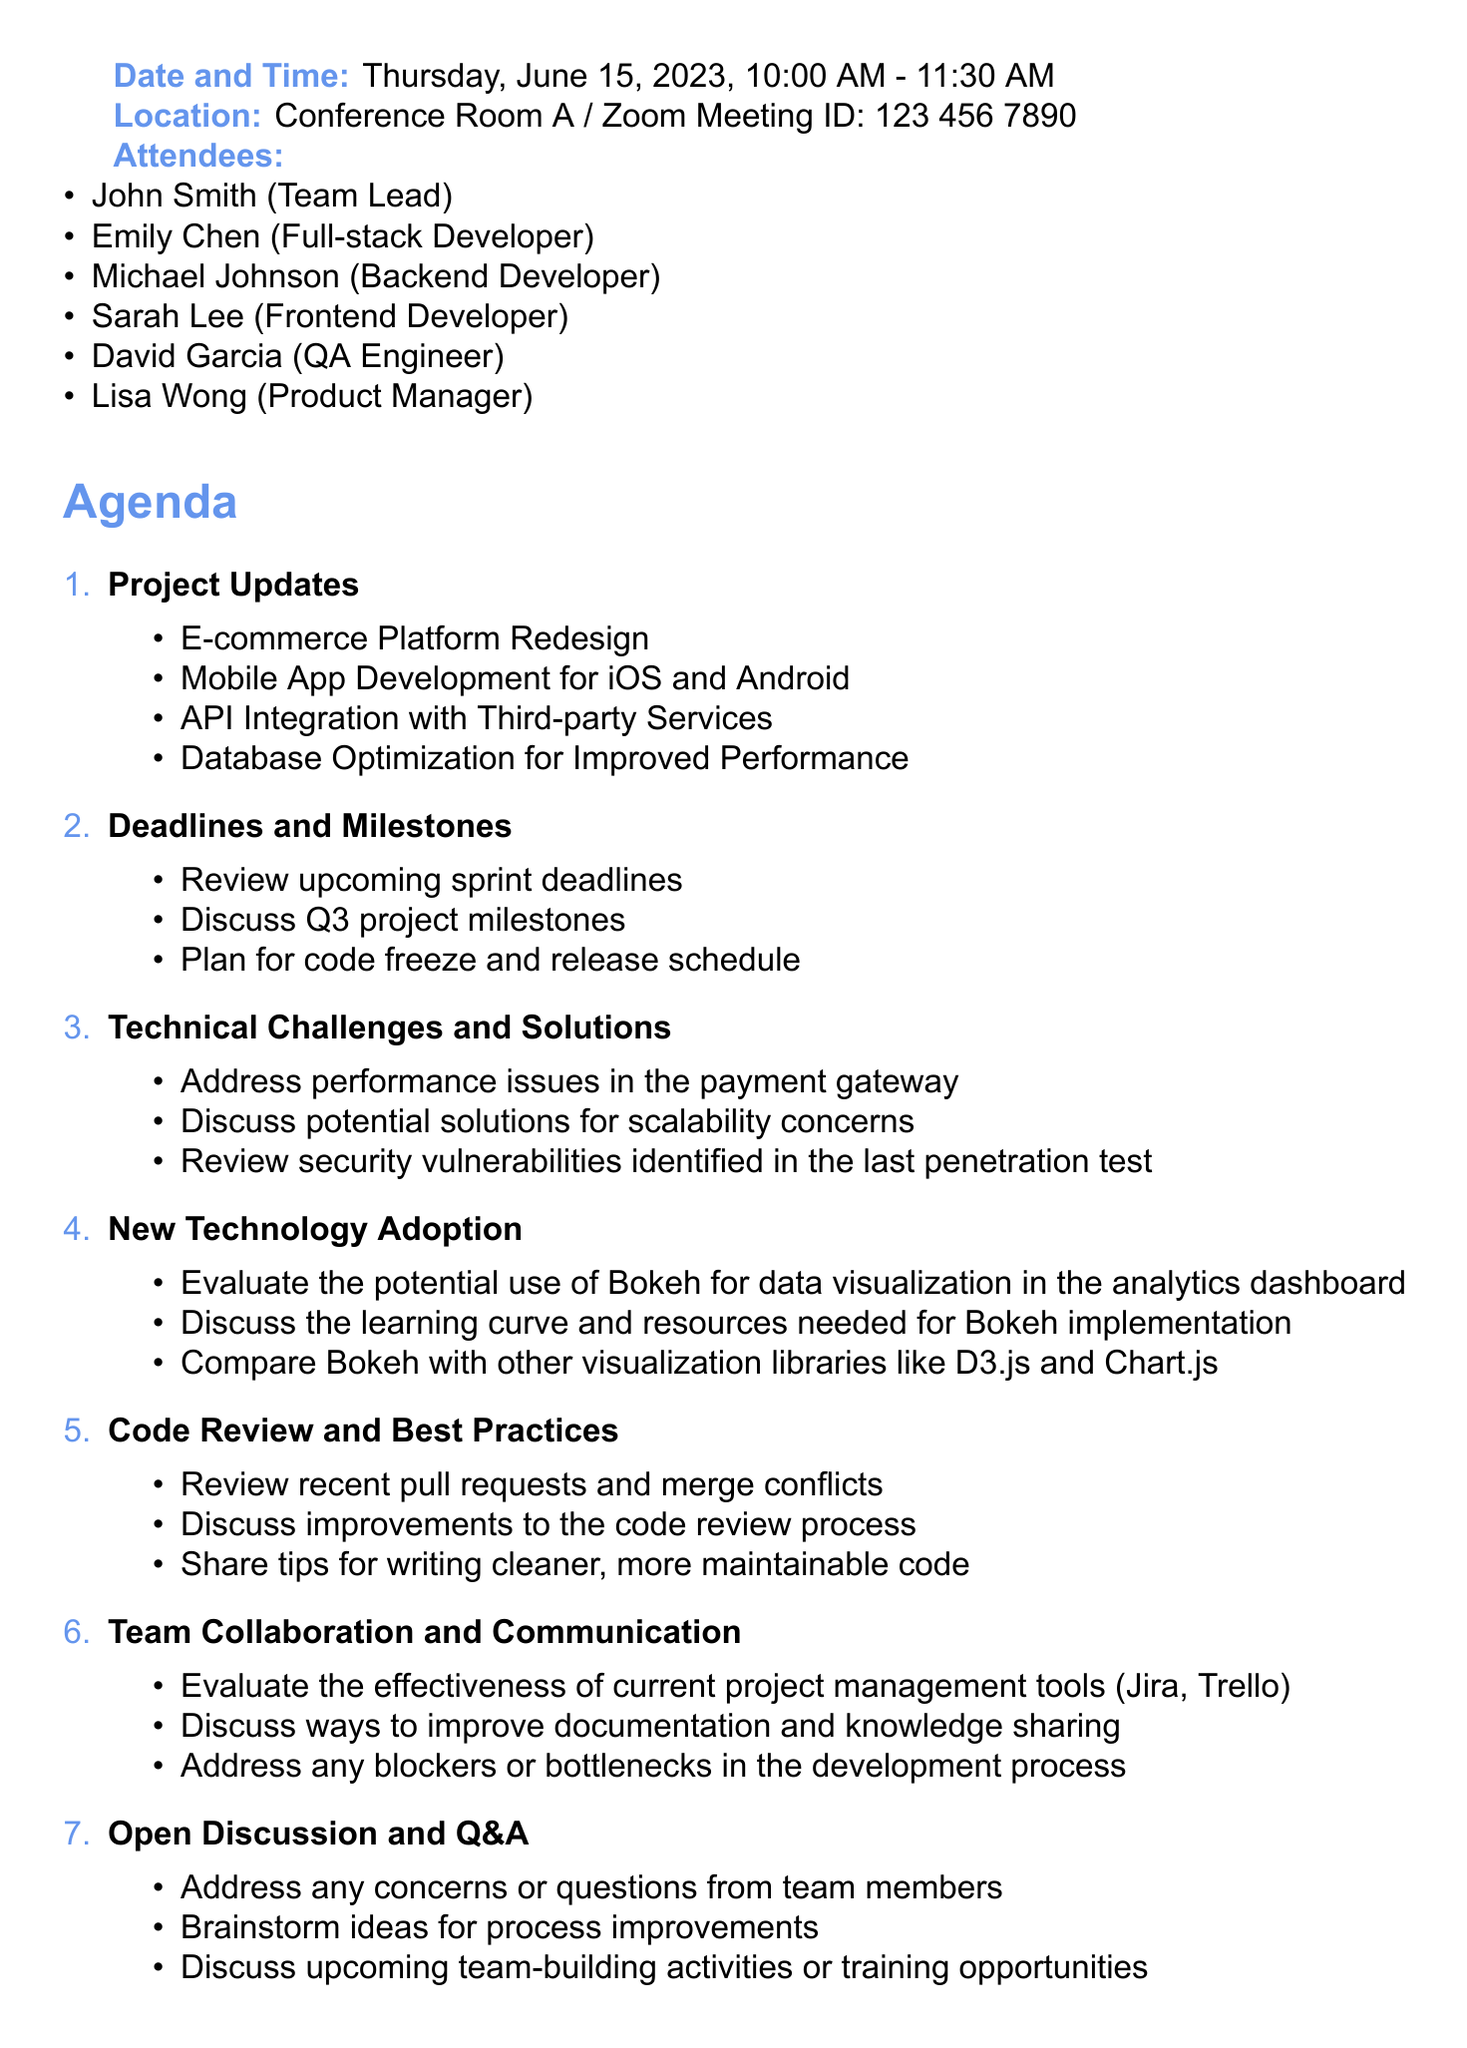What is the meeting title? The meeting title is listed at the beginning of the document.
Answer: Weekly Software Project Status Meeting Who is the team lead? The team lead's name is mentioned in the list of attendees.
Answer: John Smith What is the date and time of the meeting? The date and time are specified clearly in the document.
Answer: Thursday, June 15, 2023, 10:00 AM - 11:30 AM How many agenda items are mentioned? The total number of agenda items can be counted from the agenda section.
Answer: Seven Which technology is being evaluated for potential use? The agenda item mentions a specific technology to be evaluated.
Answer: Bokeh What is one of the action items listed? Action items are provided in a separate section of the document.
Answer: Research Bokeh library and its potential applications in our projects What type of meeting is this? The title of the meeting indicates its focus.
Answer: Status Meeting What is one topic under "Technical Challenges and Solutions"? The agenda outlines specific topics under this category.
Answer: Performance issues in the payment gateway What is the location of the meeting? The location is mentioned clearly in the document.
Answer: Conference Room A / Zoom Meeting ID: 123 456 7890 